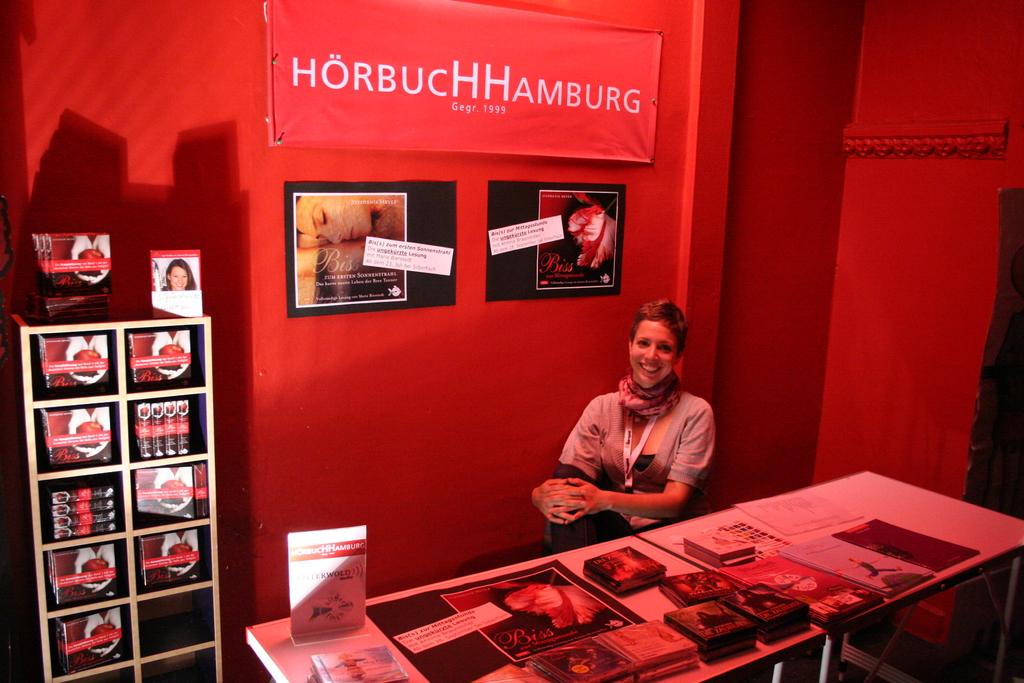What is the name of her company?
Offer a terse response. Horbuchhamburg. When does it say her company was established?
Give a very brief answer. 1999. 